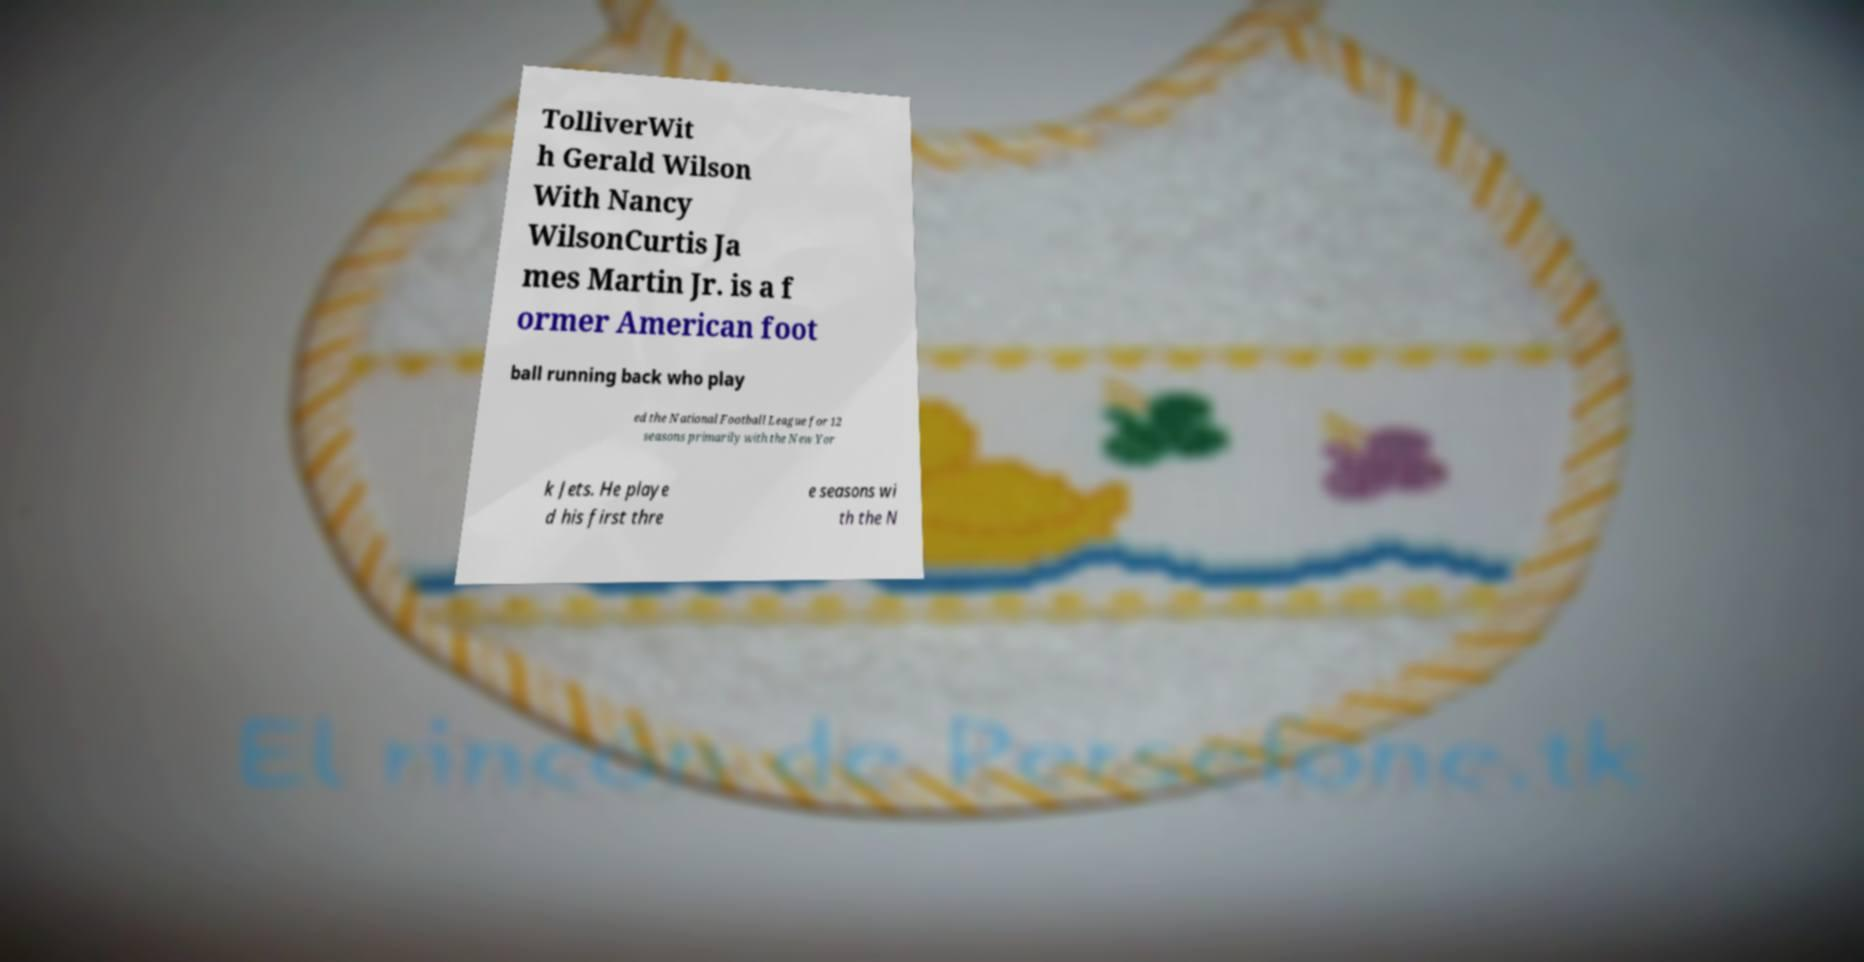I need the written content from this picture converted into text. Can you do that? TolliverWit h Gerald Wilson With Nancy WilsonCurtis Ja mes Martin Jr. is a f ormer American foot ball running back who play ed the National Football League for 12 seasons primarily with the New Yor k Jets. He playe d his first thre e seasons wi th the N 